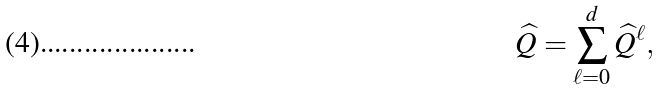Convert formula to latex. <formula><loc_0><loc_0><loc_500><loc_500>\widehat { Q } = \sum _ { \ell = 0 } ^ { d } \widehat { Q } ^ { \ell } ,</formula> 